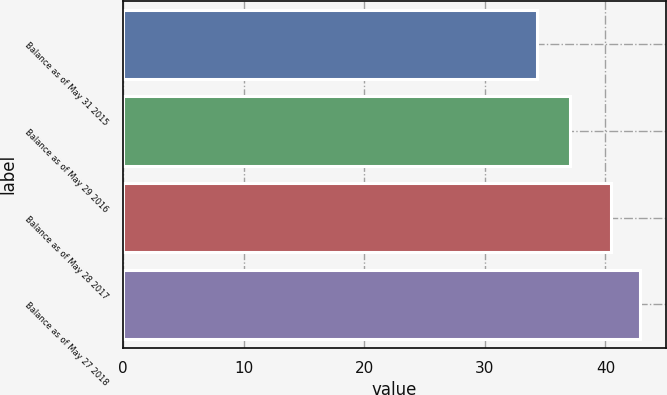Convert chart. <chart><loc_0><loc_0><loc_500><loc_500><bar_chart><fcel>Balance as of May 31 2015<fcel>Balance as of May 29 2016<fcel>Balance as of May 28 2017<fcel>Balance as of May 27 2018<nl><fcel>34.35<fcel>37.09<fcel>40.47<fcel>42.9<nl></chart> 